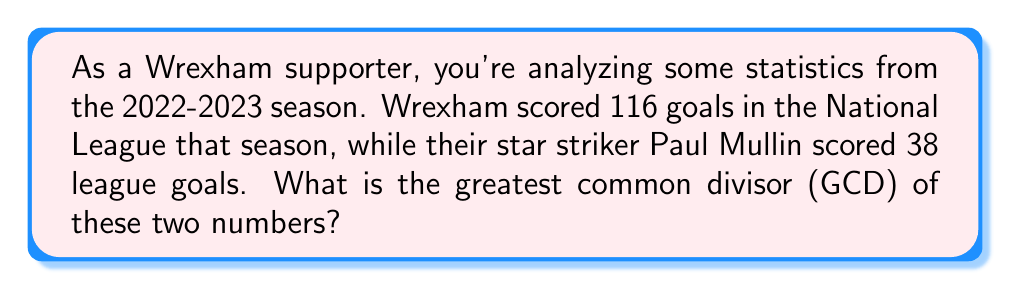Could you help me with this problem? To find the greatest common divisor of 116 and 38, we'll use the Euclidean algorithm. This algorithm states that the GCD of two numbers $a$ and $b$ is the same as the GCD of $b$ and the remainder of $a$ divided by $b$.

Let's apply the algorithm:

1) First, divide 116 by 38:
   $116 = 3 \times 38 + 2$
   The remainder is 2.

2) Now, divide 38 by 2:
   $38 = 19 \times 2 + 0$
   The remainder is 0.

3) Since we've reached a remainder of 0, the last non-zero remainder (2) is our GCD.

We can verify this:
$116 = 2 \times 58$
$38 = 2 \times 19$

Therefore, 2 is indeed the greatest common divisor of 116 and 38.

We can express this mathematically as:

$$GCD(116, 38) = 2$$
Answer: 2 